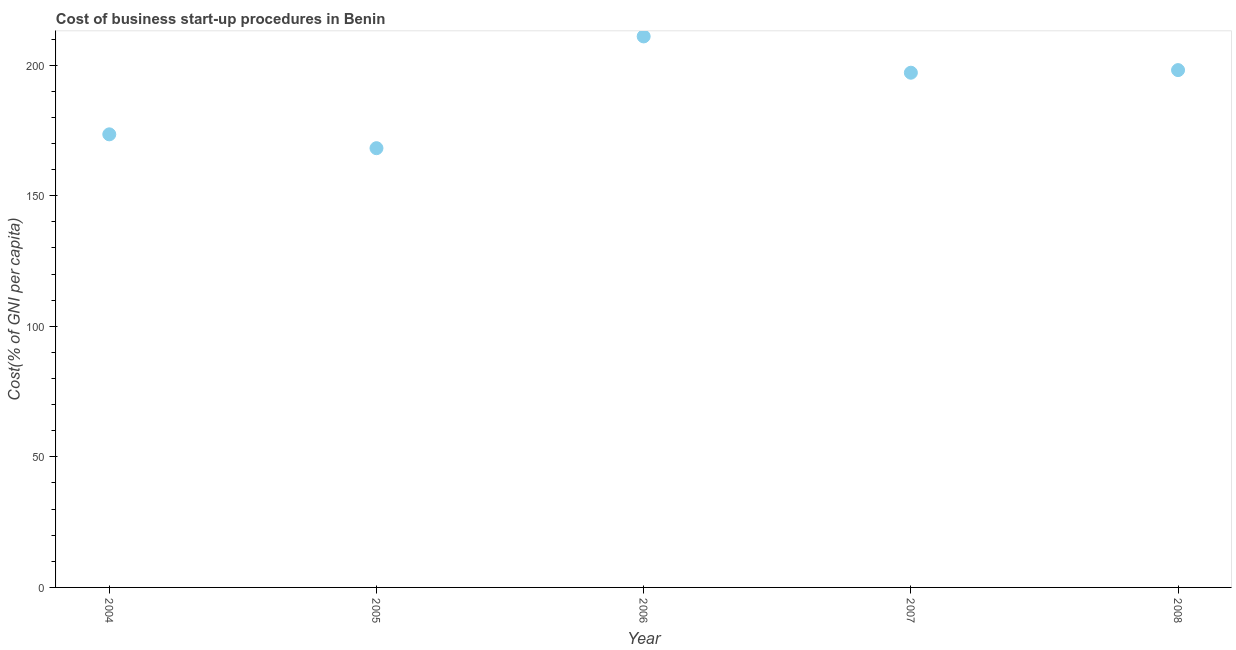What is the cost of business startup procedures in 2007?
Make the answer very short. 197.1. Across all years, what is the maximum cost of business startup procedures?
Give a very brief answer. 211. Across all years, what is the minimum cost of business startup procedures?
Offer a very short reply. 168.2. In which year was the cost of business startup procedures maximum?
Offer a very short reply. 2006. In which year was the cost of business startup procedures minimum?
Provide a short and direct response. 2005. What is the sum of the cost of business startup procedures?
Give a very brief answer. 947.9. What is the difference between the cost of business startup procedures in 2005 and 2007?
Provide a succinct answer. -28.9. What is the average cost of business startup procedures per year?
Your response must be concise. 189.58. What is the median cost of business startup procedures?
Provide a short and direct response. 197.1. Do a majority of the years between 2004 and 2005 (inclusive) have cost of business startup procedures greater than 10 %?
Provide a short and direct response. Yes. What is the ratio of the cost of business startup procedures in 2007 to that in 2008?
Offer a terse response. 0.99. Is the cost of business startup procedures in 2006 less than that in 2007?
Provide a succinct answer. No. What is the difference between the highest and the second highest cost of business startup procedures?
Your answer should be compact. 12.9. Is the sum of the cost of business startup procedures in 2004 and 2007 greater than the maximum cost of business startup procedures across all years?
Your response must be concise. Yes. What is the difference between the highest and the lowest cost of business startup procedures?
Give a very brief answer. 42.8. How many dotlines are there?
Provide a short and direct response. 1. How many years are there in the graph?
Your answer should be very brief. 5. Does the graph contain any zero values?
Give a very brief answer. No. Does the graph contain grids?
Make the answer very short. No. What is the title of the graph?
Offer a terse response. Cost of business start-up procedures in Benin. What is the label or title of the Y-axis?
Make the answer very short. Cost(% of GNI per capita). What is the Cost(% of GNI per capita) in 2004?
Make the answer very short. 173.5. What is the Cost(% of GNI per capita) in 2005?
Make the answer very short. 168.2. What is the Cost(% of GNI per capita) in 2006?
Keep it short and to the point. 211. What is the Cost(% of GNI per capita) in 2007?
Provide a succinct answer. 197.1. What is the Cost(% of GNI per capita) in 2008?
Give a very brief answer. 198.1. What is the difference between the Cost(% of GNI per capita) in 2004 and 2006?
Give a very brief answer. -37.5. What is the difference between the Cost(% of GNI per capita) in 2004 and 2007?
Provide a succinct answer. -23.6. What is the difference between the Cost(% of GNI per capita) in 2004 and 2008?
Provide a succinct answer. -24.6. What is the difference between the Cost(% of GNI per capita) in 2005 and 2006?
Provide a succinct answer. -42.8. What is the difference between the Cost(% of GNI per capita) in 2005 and 2007?
Your response must be concise. -28.9. What is the difference between the Cost(% of GNI per capita) in 2005 and 2008?
Give a very brief answer. -29.9. What is the difference between the Cost(% of GNI per capita) in 2006 and 2007?
Your answer should be compact. 13.9. What is the difference between the Cost(% of GNI per capita) in 2007 and 2008?
Provide a succinct answer. -1. What is the ratio of the Cost(% of GNI per capita) in 2004 to that in 2005?
Your response must be concise. 1.03. What is the ratio of the Cost(% of GNI per capita) in 2004 to that in 2006?
Your answer should be compact. 0.82. What is the ratio of the Cost(% of GNI per capita) in 2004 to that in 2007?
Your response must be concise. 0.88. What is the ratio of the Cost(% of GNI per capita) in 2004 to that in 2008?
Make the answer very short. 0.88. What is the ratio of the Cost(% of GNI per capita) in 2005 to that in 2006?
Your response must be concise. 0.8. What is the ratio of the Cost(% of GNI per capita) in 2005 to that in 2007?
Your answer should be compact. 0.85. What is the ratio of the Cost(% of GNI per capita) in 2005 to that in 2008?
Make the answer very short. 0.85. What is the ratio of the Cost(% of GNI per capita) in 2006 to that in 2007?
Your response must be concise. 1.07. What is the ratio of the Cost(% of GNI per capita) in 2006 to that in 2008?
Your answer should be compact. 1.06. 